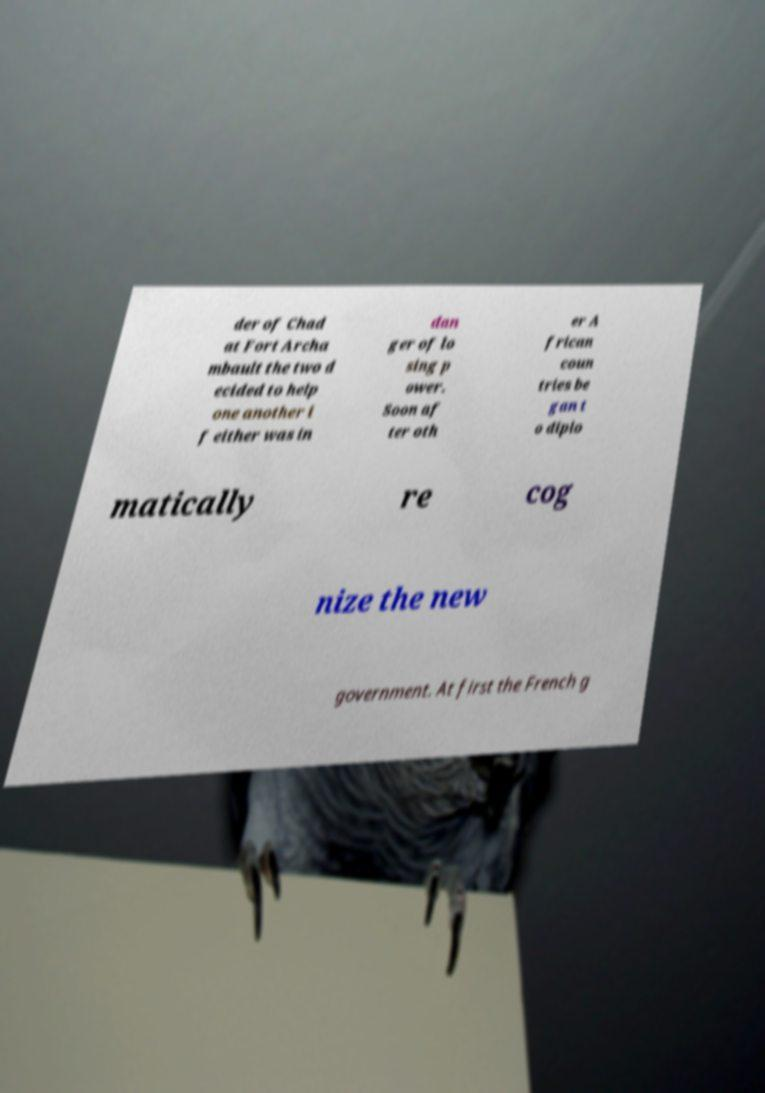Could you extract and type out the text from this image? der of Chad at Fort Archa mbault the two d ecided to help one another i f either was in dan ger of lo sing p ower. Soon af ter oth er A frican coun tries be gan t o diplo matically re cog nize the new government. At first the French g 